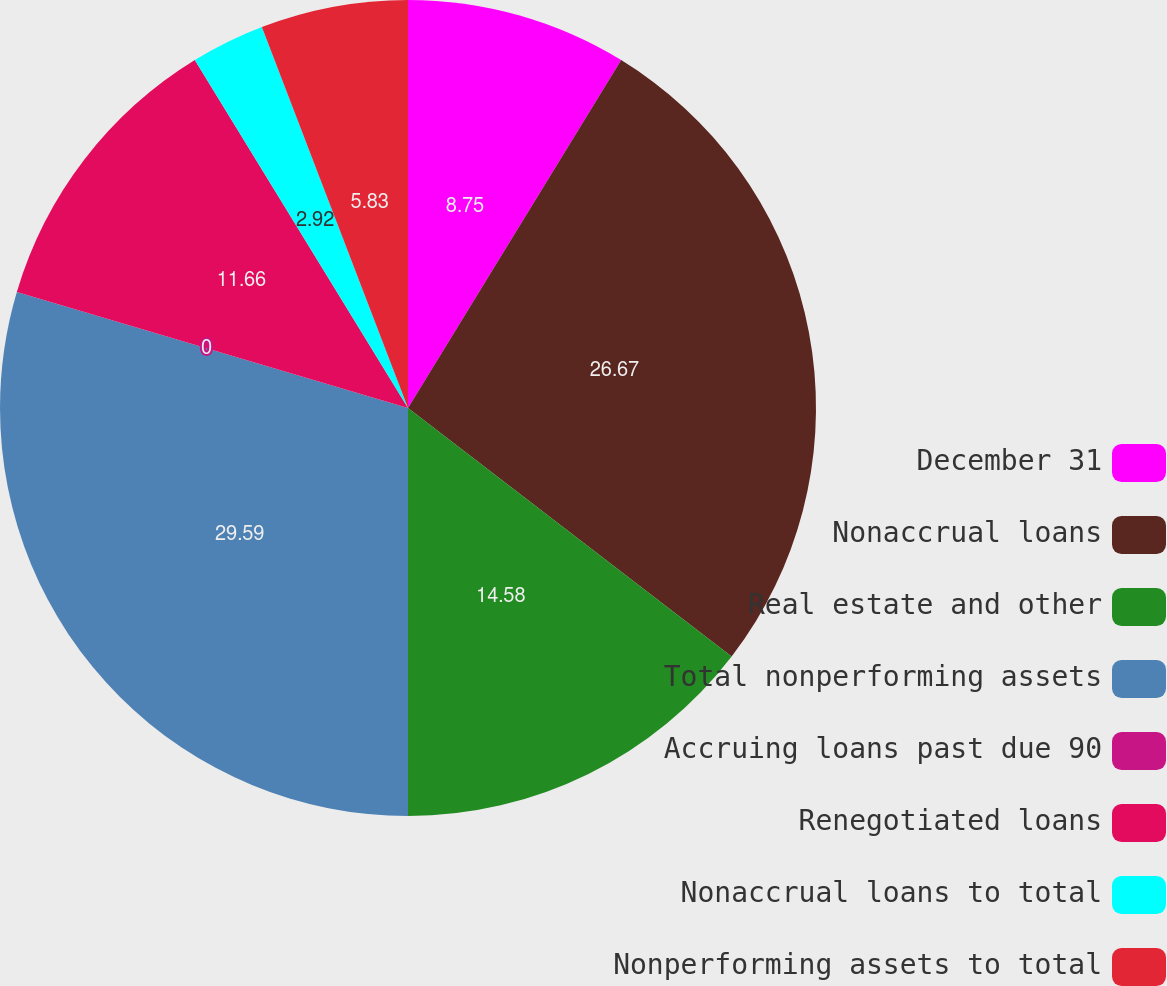Convert chart to OTSL. <chart><loc_0><loc_0><loc_500><loc_500><pie_chart><fcel>December 31<fcel>Nonaccrual loans<fcel>Real estate and other<fcel>Total nonperforming assets<fcel>Accruing loans past due 90<fcel>Renegotiated loans<fcel>Nonaccrual loans to total<fcel>Nonperforming assets to total<nl><fcel>8.75%<fcel>26.67%<fcel>14.58%<fcel>29.59%<fcel>0.0%<fcel>11.66%<fcel>2.92%<fcel>5.83%<nl></chart> 